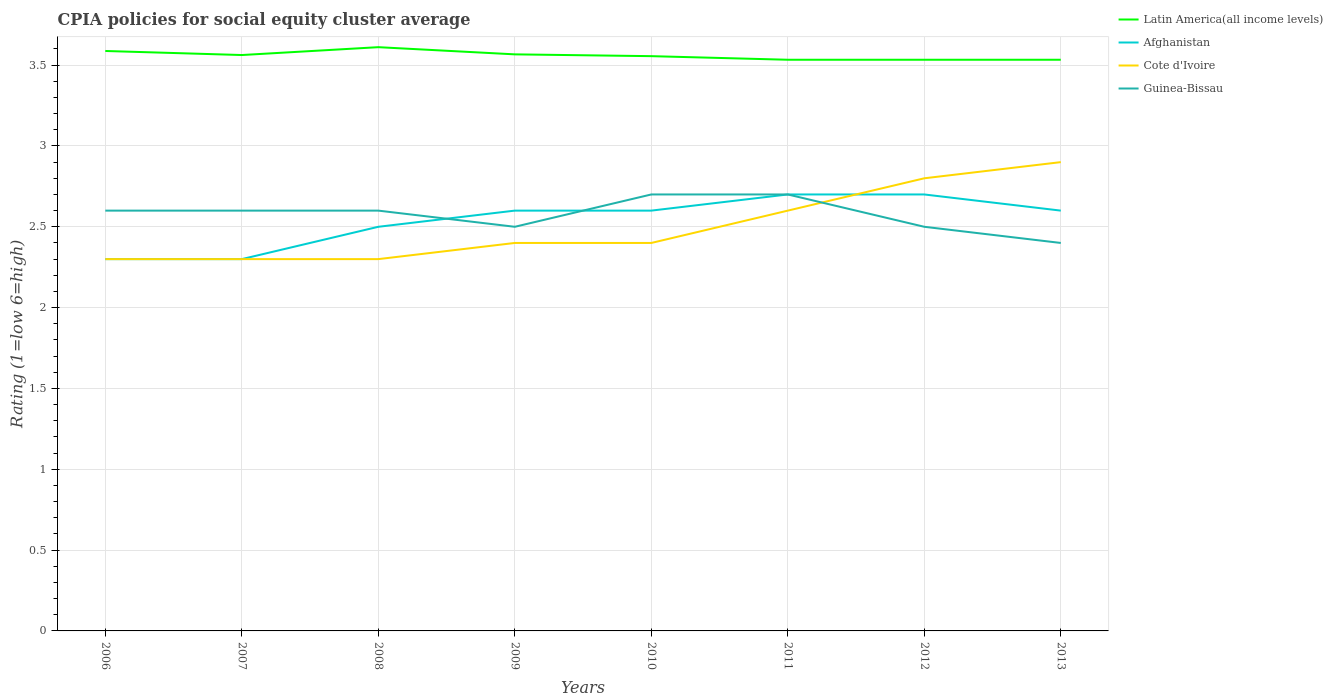Does the line corresponding to Latin America(all income levels) intersect with the line corresponding to Afghanistan?
Give a very brief answer. No. Across all years, what is the maximum CPIA rating in Latin America(all income levels)?
Ensure brevity in your answer.  3.53. What is the total CPIA rating in Afghanistan in the graph?
Offer a terse response. -0.3. What is the difference between the highest and the second highest CPIA rating in Guinea-Bissau?
Give a very brief answer. 0.3. What is the difference between two consecutive major ticks on the Y-axis?
Offer a very short reply. 0.5. Are the values on the major ticks of Y-axis written in scientific E-notation?
Your response must be concise. No. Does the graph contain any zero values?
Ensure brevity in your answer.  No. Does the graph contain grids?
Ensure brevity in your answer.  Yes. Where does the legend appear in the graph?
Keep it short and to the point. Top right. What is the title of the graph?
Offer a very short reply. CPIA policies for social equity cluster average. What is the label or title of the X-axis?
Your response must be concise. Years. What is the label or title of the Y-axis?
Your answer should be compact. Rating (1=low 6=high). What is the Rating (1=low 6=high) in Latin America(all income levels) in 2006?
Keep it short and to the point. 3.59. What is the Rating (1=low 6=high) in Latin America(all income levels) in 2007?
Offer a terse response. 3.56. What is the Rating (1=low 6=high) in Guinea-Bissau in 2007?
Your answer should be compact. 2.6. What is the Rating (1=low 6=high) in Latin America(all income levels) in 2008?
Ensure brevity in your answer.  3.61. What is the Rating (1=low 6=high) of Afghanistan in 2008?
Offer a very short reply. 2.5. What is the Rating (1=low 6=high) in Guinea-Bissau in 2008?
Provide a succinct answer. 2.6. What is the Rating (1=low 6=high) in Latin America(all income levels) in 2009?
Provide a succinct answer. 3.57. What is the Rating (1=low 6=high) in Cote d'Ivoire in 2009?
Offer a very short reply. 2.4. What is the Rating (1=low 6=high) in Guinea-Bissau in 2009?
Your answer should be very brief. 2.5. What is the Rating (1=low 6=high) in Latin America(all income levels) in 2010?
Make the answer very short. 3.56. What is the Rating (1=low 6=high) in Afghanistan in 2010?
Provide a succinct answer. 2.6. What is the Rating (1=low 6=high) in Guinea-Bissau in 2010?
Give a very brief answer. 2.7. What is the Rating (1=low 6=high) of Latin America(all income levels) in 2011?
Offer a very short reply. 3.53. What is the Rating (1=low 6=high) of Cote d'Ivoire in 2011?
Make the answer very short. 2.6. What is the Rating (1=low 6=high) of Latin America(all income levels) in 2012?
Your response must be concise. 3.53. What is the Rating (1=low 6=high) in Latin America(all income levels) in 2013?
Offer a terse response. 3.53. Across all years, what is the maximum Rating (1=low 6=high) of Latin America(all income levels)?
Ensure brevity in your answer.  3.61. Across all years, what is the maximum Rating (1=low 6=high) of Cote d'Ivoire?
Your answer should be very brief. 2.9. Across all years, what is the minimum Rating (1=low 6=high) of Latin America(all income levels)?
Make the answer very short. 3.53. Across all years, what is the minimum Rating (1=low 6=high) of Afghanistan?
Your response must be concise. 2.3. Across all years, what is the minimum Rating (1=low 6=high) of Guinea-Bissau?
Ensure brevity in your answer.  2.4. What is the total Rating (1=low 6=high) of Latin America(all income levels) in the graph?
Make the answer very short. 28.48. What is the total Rating (1=low 6=high) in Afghanistan in the graph?
Provide a short and direct response. 20.3. What is the total Rating (1=low 6=high) in Cote d'Ivoire in the graph?
Give a very brief answer. 20. What is the total Rating (1=low 6=high) of Guinea-Bissau in the graph?
Your answer should be compact. 20.6. What is the difference between the Rating (1=low 6=high) in Latin America(all income levels) in 2006 and that in 2007?
Make the answer very short. 0.03. What is the difference between the Rating (1=low 6=high) in Cote d'Ivoire in 2006 and that in 2007?
Your answer should be very brief. 0. What is the difference between the Rating (1=low 6=high) in Guinea-Bissau in 2006 and that in 2007?
Make the answer very short. 0. What is the difference between the Rating (1=low 6=high) in Latin America(all income levels) in 2006 and that in 2008?
Your answer should be compact. -0.02. What is the difference between the Rating (1=low 6=high) in Guinea-Bissau in 2006 and that in 2008?
Your answer should be compact. 0. What is the difference between the Rating (1=low 6=high) of Latin America(all income levels) in 2006 and that in 2009?
Your answer should be compact. 0.02. What is the difference between the Rating (1=low 6=high) of Latin America(all income levels) in 2006 and that in 2010?
Offer a very short reply. 0.03. What is the difference between the Rating (1=low 6=high) of Guinea-Bissau in 2006 and that in 2010?
Your answer should be very brief. -0.1. What is the difference between the Rating (1=low 6=high) in Latin America(all income levels) in 2006 and that in 2011?
Provide a succinct answer. 0.05. What is the difference between the Rating (1=low 6=high) in Cote d'Ivoire in 2006 and that in 2011?
Provide a short and direct response. -0.3. What is the difference between the Rating (1=low 6=high) of Guinea-Bissau in 2006 and that in 2011?
Provide a short and direct response. -0.1. What is the difference between the Rating (1=low 6=high) of Latin America(all income levels) in 2006 and that in 2012?
Give a very brief answer. 0.05. What is the difference between the Rating (1=low 6=high) of Afghanistan in 2006 and that in 2012?
Your answer should be compact. -0.4. What is the difference between the Rating (1=low 6=high) in Guinea-Bissau in 2006 and that in 2012?
Your answer should be compact. 0.1. What is the difference between the Rating (1=low 6=high) of Latin America(all income levels) in 2006 and that in 2013?
Keep it short and to the point. 0.05. What is the difference between the Rating (1=low 6=high) of Cote d'Ivoire in 2006 and that in 2013?
Give a very brief answer. -0.6. What is the difference between the Rating (1=low 6=high) in Guinea-Bissau in 2006 and that in 2013?
Offer a very short reply. 0.2. What is the difference between the Rating (1=low 6=high) in Latin America(all income levels) in 2007 and that in 2008?
Your answer should be very brief. -0.05. What is the difference between the Rating (1=low 6=high) of Afghanistan in 2007 and that in 2008?
Provide a succinct answer. -0.2. What is the difference between the Rating (1=low 6=high) of Latin America(all income levels) in 2007 and that in 2009?
Your answer should be compact. -0. What is the difference between the Rating (1=low 6=high) of Latin America(all income levels) in 2007 and that in 2010?
Your response must be concise. 0.01. What is the difference between the Rating (1=low 6=high) in Cote d'Ivoire in 2007 and that in 2010?
Ensure brevity in your answer.  -0.1. What is the difference between the Rating (1=low 6=high) in Guinea-Bissau in 2007 and that in 2010?
Provide a succinct answer. -0.1. What is the difference between the Rating (1=low 6=high) of Latin America(all income levels) in 2007 and that in 2011?
Make the answer very short. 0.03. What is the difference between the Rating (1=low 6=high) of Cote d'Ivoire in 2007 and that in 2011?
Your answer should be very brief. -0.3. What is the difference between the Rating (1=low 6=high) of Latin America(all income levels) in 2007 and that in 2012?
Ensure brevity in your answer.  0.03. What is the difference between the Rating (1=low 6=high) in Latin America(all income levels) in 2007 and that in 2013?
Offer a very short reply. 0.03. What is the difference between the Rating (1=low 6=high) in Afghanistan in 2007 and that in 2013?
Provide a short and direct response. -0.3. What is the difference between the Rating (1=low 6=high) of Guinea-Bissau in 2007 and that in 2013?
Your response must be concise. 0.2. What is the difference between the Rating (1=low 6=high) of Latin America(all income levels) in 2008 and that in 2009?
Ensure brevity in your answer.  0.04. What is the difference between the Rating (1=low 6=high) in Afghanistan in 2008 and that in 2009?
Ensure brevity in your answer.  -0.1. What is the difference between the Rating (1=low 6=high) in Guinea-Bissau in 2008 and that in 2009?
Offer a terse response. 0.1. What is the difference between the Rating (1=low 6=high) in Latin America(all income levels) in 2008 and that in 2010?
Keep it short and to the point. 0.06. What is the difference between the Rating (1=low 6=high) of Afghanistan in 2008 and that in 2010?
Your response must be concise. -0.1. What is the difference between the Rating (1=low 6=high) in Guinea-Bissau in 2008 and that in 2010?
Provide a succinct answer. -0.1. What is the difference between the Rating (1=low 6=high) of Latin America(all income levels) in 2008 and that in 2011?
Your answer should be compact. 0.08. What is the difference between the Rating (1=low 6=high) of Afghanistan in 2008 and that in 2011?
Offer a terse response. -0.2. What is the difference between the Rating (1=low 6=high) in Guinea-Bissau in 2008 and that in 2011?
Your response must be concise. -0.1. What is the difference between the Rating (1=low 6=high) of Latin America(all income levels) in 2008 and that in 2012?
Ensure brevity in your answer.  0.08. What is the difference between the Rating (1=low 6=high) in Cote d'Ivoire in 2008 and that in 2012?
Offer a very short reply. -0.5. What is the difference between the Rating (1=low 6=high) in Guinea-Bissau in 2008 and that in 2012?
Ensure brevity in your answer.  0.1. What is the difference between the Rating (1=low 6=high) in Latin America(all income levels) in 2008 and that in 2013?
Offer a terse response. 0.08. What is the difference between the Rating (1=low 6=high) in Cote d'Ivoire in 2008 and that in 2013?
Your answer should be compact. -0.6. What is the difference between the Rating (1=low 6=high) of Guinea-Bissau in 2008 and that in 2013?
Your answer should be very brief. 0.2. What is the difference between the Rating (1=low 6=high) in Latin America(all income levels) in 2009 and that in 2010?
Offer a terse response. 0.01. What is the difference between the Rating (1=low 6=high) in Guinea-Bissau in 2009 and that in 2010?
Ensure brevity in your answer.  -0.2. What is the difference between the Rating (1=low 6=high) in Latin America(all income levels) in 2009 and that in 2011?
Give a very brief answer. 0.03. What is the difference between the Rating (1=low 6=high) of Cote d'Ivoire in 2009 and that in 2011?
Provide a short and direct response. -0.2. What is the difference between the Rating (1=low 6=high) in Latin America(all income levels) in 2009 and that in 2012?
Give a very brief answer. 0.03. What is the difference between the Rating (1=low 6=high) in Guinea-Bissau in 2009 and that in 2012?
Offer a very short reply. 0. What is the difference between the Rating (1=low 6=high) in Latin America(all income levels) in 2009 and that in 2013?
Your answer should be compact. 0.03. What is the difference between the Rating (1=low 6=high) of Latin America(all income levels) in 2010 and that in 2011?
Give a very brief answer. 0.02. What is the difference between the Rating (1=low 6=high) of Latin America(all income levels) in 2010 and that in 2012?
Provide a short and direct response. 0.02. What is the difference between the Rating (1=low 6=high) of Afghanistan in 2010 and that in 2012?
Offer a terse response. -0.1. What is the difference between the Rating (1=low 6=high) of Latin America(all income levels) in 2010 and that in 2013?
Ensure brevity in your answer.  0.02. What is the difference between the Rating (1=low 6=high) in Afghanistan in 2010 and that in 2013?
Ensure brevity in your answer.  0. What is the difference between the Rating (1=low 6=high) of Guinea-Bissau in 2010 and that in 2013?
Ensure brevity in your answer.  0.3. What is the difference between the Rating (1=low 6=high) in Latin America(all income levels) in 2011 and that in 2012?
Keep it short and to the point. 0. What is the difference between the Rating (1=low 6=high) of Afghanistan in 2011 and that in 2012?
Ensure brevity in your answer.  0. What is the difference between the Rating (1=low 6=high) of Guinea-Bissau in 2011 and that in 2012?
Offer a very short reply. 0.2. What is the difference between the Rating (1=low 6=high) in Latin America(all income levels) in 2011 and that in 2013?
Keep it short and to the point. 0. What is the difference between the Rating (1=low 6=high) of Cote d'Ivoire in 2011 and that in 2013?
Keep it short and to the point. -0.3. What is the difference between the Rating (1=low 6=high) of Afghanistan in 2012 and that in 2013?
Offer a terse response. 0.1. What is the difference between the Rating (1=low 6=high) of Latin America(all income levels) in 2006 and the Rating (1=low 6=high) of Afghanistan in 2007?
Your answer should be compact. 1.29. What is the difference between the Rating (1=low 6=high) in Latin America(all income levels) in 2006 and the Rating (1=low 6=high) in Cote d'Ivoire in 2007?
Your response must be concise. 1.29. What is the difference between the Rating (1=low 6=high) of Latin America(all income levels) in 2006 and the Rating (1=low 6=high) of Guinea-Bissau in 2007?
Provide a succinct answer. 0.99. What is the difference between the Rating (1=low 6=high) in Afghanistan in 2006 and the Rating (1=low 6=high) in Guinea-Bissau in 2007?
Your response must be concise. -0.3. What is the difference between the Rating (1=low 6=high) in Cote d'Ivoire in 2006 and the Rating (1=low 6=high) in Guinea-Bissau in 2007?
Give a very brief answer. -0.3. What is the difference between the Rating (1=low 6=high) of Latin America(all income levels) in 2006 and the Rating (1=low 6=high) of Afghanistan in 2008?
Your answer should be very brief. 1.09. What is the difference between the Rating (1=low 6=high) in Latin America(all income levels) in 2006 and the Rating (1=low 6=high) in Cote d'Ivoire in 2008?
Provide a short and direct response. 1.29. What is the difference between the Rating (1=low 6=high) in Latin America(all income levels) in 2006 and the Rating (1=low 6=high) in Guinea-Bissau in 2008?
Your answer should be compact. 0.99. What is the difference between the Rating (1=low 6=high) of Latin America(all income levels) in 2006 and the Rating (1=low 6=high) of Afghanistan in 2009?
Ensure brevity in your answer.  0.99. What is the difference between the Rating (1=low 6=high) in Latin America(all income levels) in 2006 and the Rating (1=low 6=high) in Cote d'Ivoire in 2009?
Your answer should be compact. 1.19. What is the difference between the Rating (1=low 6=high) in Latin America(all income levels) in 2006 and the Rating (1=low 6=high) in Guinea-Bissau in 2009?
Provide a succinct answer. 1.09. What is the difference between the Rating (1=low 6=high) in Afghanistan in 2006 and the Rating (1=low 6=high) in Guinea-Bissau in 2009?
Make the answer very short. -0.2. What is the difference between the Rating (1=low 6=high) of Cote d'Ivoire in 2006 and the Rating (1=low 6=high) of Guinea-Bissau in 2009?
Offer a very short reply. -0.2. What is the difference between the Rating (1=low 6=high) of Latin America(all income levels) in 2006 and the Rating (1=low 6=high) of Afghanistan in 2010?
Provide a succinct answer. 0.99. What is the difference between the Rating (1=low 6=high) in Latin America(all income levels) in 2006 and the Rating (1=low 6=high) in Cote d'Ivoire in 2010?
Provide a short and direct response. 1.19. What is the difference between the Rating (1=low 6=high) of Latin America(all income levels) in 2006 and the Rating (1=low 6=high) of Guinea-Bissau in 2010?
Offer a very short reply. 0.89. What is the difference between the Rating (1=low 6=high) in Cote d'Ivoire in 2006 and the Rating (1=low 6=high) in Guinea-Bissau in 2010?
Provide a succinct answer. -0.4. What is the difference between the Rating (1=low 6=high) in Latin America(all income levels) in 2006 and the Rating (1=low 6=high) in Afghanistan in 2011?
Keep it short and to the point. 0.89. What is the difference between the Rating (1=low 6=high) in Latin America(all income levels) in 2006 and the Rating (1=low 6=high) in Cote d'Ivoire in 2011?
Provide a succinct answer. 0.99. What is the difference between the Rating (1=low 6=high) of Latin America(all income levels) in 2006 and the Rating (1=low 6=high) of Guinea-Bissau in 2011?
Provide a short and direct response. 0.89. What is the difference between the Rating (1=low 6=high) of Afghanistan in 2006 and the Rating (1=low 6=high) of Cote d'Ivoire in 2011?
Keep it short and to the point. -0.3. What is the difference between the Rating (1=low 6=high) in Afghanistan in 2006 and the Rating (1=low 6=high) in Guinea-Bissau in 2011?
Your answer should be compact. -0.4. What is the difference between the Rating (1=low 6=high) in Cote d'Ivoire in 2006 and the Rating (1=low 6=high) in Guinea-Bissau in 2011?
Your answer should be very brief. -0.4. What is the difference between the Rating (1=low 6=high) in Latin America(all income levels) in 2006 and the Rating (1=low 6=high) in Afghanistan in 2012?
Your answer should be compact. 0.89. What is the difference between the Rating (1=low 6=high) of Latin America(all income levels) in 2006 and the Rating (1=low 6=high) of Cote d'Ivoire in 2012?
Your response must be concise. 0.79. What is the difference between the Rating (1=low 6=high) in Latin America(all income levels) in 2006 and the Rating (1=low 6=high) in Guinea-Bissau in 2012?
Your response must be concise. 1.09. What is the difference between the Rating (1=low 6=high) of Afghanistan in 2006 and the Rating (1=low 6=high) of Guinea-Bissau in 2012?
Offer a terse response. -0.2. What is the difference between the Rating (1=low 6=high) of Latin America(all income levels) in 2006 and the Rating (1=low 6=high) of Afghanistan in 2013?
Your answer should be very brief. 0.99. What is the difference between the Rating (1=low 6=high) in Latin America(all income levels) in 2006 and the Rating (1=low 6=high) in Cote d'Ivoire in 2013?
Your answer should be compact. 0.69. What is the difference between the Rating (1=low 6=high) in Latin America(all income levels) in 2006 and the Rating (1=low 6=high) in Guinea-Bissau in 2013?
Ensure brevity in your answer.  1.19. What is the difference between the Rating (1=low 6=high) in Afghanistan in 2006 and the Rating (1=low 6=high) in Cote d'Ivoire in 2013?
Your response must be concise. -0.6. What is the difference between the Rating (1=low 6=high) in Latin America(all income levels) in 2007 and the Rating (1=low 6=high) in Afghanistan in 2008?
Ensure brevity in your answer.  1.06. What is the difference between the Rating (1=low 6=high) of Latin America(all income levels) in 2007 and the Rating (1=low 6=high) of Cote d'Ivoire in 2008?
Keep it short and to the point. 1.26. What is the difference between the Rating (1=low 6=high) of Latin America(all income levels) in 2007 and the Rating (1=low 6=high) of Guinea-Bissau in 2008?
Provide a short and direct response. 0.96. What is the difference between the Rating (1=low 6=high) of Latin America(all income levels) in 2007 and the Rating (1=low 6=high) of Afghanistan in 2009?
Make the answer very short. 0.96. What is the difference between the Rating (1=low 6=high) in Latin America(all income levels) in 2007 and the Rating (1=low 6=high) in Cote d'Ivoire in 2009?
Offer a very short reply. 1.16. What is the difference between the Rating (1=low 6=high) of Afghanistan in 2007 and the Rating (1=low 6=high) of Cote d'Ivoire in 2009?
Ensure brevity in your answer.  -0.1. What is the difference between the Rating (1=low 6=high) in Cote d'Ivoire in 2007 and the Rating (1=low 6=high) in Guinea-Bissau in 2009?
Give a very brief answer. -0.2. What is the difference between the Rating (1=low 6=high) of Latin America(all income levels) in 2007 and the Rating (1=low 6=high) of Afghanistan in 2010?
Provide a succinct answer. 0.96. What is the difference between the Rating (1=low 6=high) of Latin America(all income levels) in 2007 and the Rating (1=low 6=high) of Cote d'Ivoire in 2010?
Ensure brevity in your answer.  1.16. What is the difference between the Rating (1=low 6=high) of Latin America(all income levels) in 2007 and the Rating (1=low 6=high) of Guinea-Bissau in 2010?
Make the answer very short. 0.86. What is the difference between the Rating (1=low 6=high) of Latin America(all income levels) in 2007 and the Rating (1=low 6=high) of Afghanistan in 2011?
Provide a short and direct response. 0.86. What is the difference between the Rating (1=low 6=high) in Latin America(all income levels) in 2007 and the Rating (1=low 6=high) in Cote d'Ivoire in 2011?
Keep it short and to the point. 0.96. What is the difference between the Rating (1=low 6=high) in Latin America(all income levels) in 2007 and the Rating (1=low 6=high) in Guinea-Bissau in 2011?
Offer a very short reply. 0.86. What is the difference between the Rating (1=low 6=high) of Afghanistan in 2007 and the Rating (1=low 6=high) of Cote d'Ivoire in 2011?
Provide a short and direct response. -0.3. What is the difference between the Rating (1=low 6=high) in Afghanistan in 2007 and the Rating (1=low 6=high) in Guinea-Bissau in 2011?
Keep it short and to the point. -0.4. What is the difference between the Rating (1=low 6=high) in Cote d'Ivoire in 2007 and the Rating (1=low 6=high) in Guinea-Bissau in 2011?
Provide a short and direct response. -0.4. What is the difference between the Rating (1=low 6=high) of Latin America(all income levels) in 2007 and the Rating (1=low 6=high) of Afghanistan in 2012?
Your answer should be compact. 0.86. What is the difference between the Rating (1=low 6=high) of Latin America(all income levels) in 2007 and the Rating (1=low 6=high) of Cote d'Ivoire in 2012?
Offer a very short reply. 0.76. What is the difference between the Rating (1=low 6=high) in Latin America(all income levels) in 2007 and the Rating (1=low 6=high) in Guinea-Bissau in 2012?
Your answer should be compact. 1.06. What is the difference between the Rating (1=low 6=high) in Afghanistan in 2007 and the Rating (1=low 6=high) in Cote d'Ivoire in 2012?
Your response must be concise. -0.5. What is the difference between the Rating (1=low 6=high) in Cote d'Ivoire in 2007 and the Rating (1=low 6=high) in Guinea-Bissau in 2012?
Give a very brief answer. -0.2. What is the difference between the Rating (1=low 6=high) of Latin America(all income levels) in 2007 and the Rating (1=low 6=high) of Afghanistan in 2013?
Offer a terse response. 0.96. What is the difference between the Rating (1=low 6=high) in Latin America(all income levels) in 2007 and the Rating (1=low 6=high) in Cote d'Ivoire in 2013?
Keep it short and to the point. 0.66. What is the difference between the Rating (1=low 6=high) in Latin America(all income levels) in 2007 and the Rating (1=low 6=high) in Guinea-Bissau in 2013?
Make the answer very short. 1.16. What is the difference between the Rating (1=low 6=high) of Latin America(all income levels) in 2008 and the Rating (1=low 6=high) of Afghanistan in 2009?
Provide a short and direct response. 1.01. What is the difference between the Rating (1=low 6=high) of Latin America(all income levels) in 2008 and the Rating (1=low 6=high) of Cote d'Ivoire in 2009?
Offer a very short reply. 1.21. What is the difference between the Rating (1=low 6=high) in Latin America(all income levels) in 2008 and the Rating (1=low 6=high) in Guinea-Bissau in 2009?
Your response must be concise. 1.11. What is the difference between the Rating (1=low 6=high) in Afghanistan in 2008 and the Rating (1=low 6=high) in Cote d'Ivoire in 2009?
Offer a very short reply. 0.1. What is the difference between the Rating (1=low 6=high) in Afghanistan in 2008 and the Rating (1=low 6=high) in Guinea-Bissau in 2009?
Your answer should be compact. 0. What is the difference between the Rating (1=low 6=high) of Cote d'Ivoire in 2008 and the Rating (1=low 6=high) of Guinea-Bissau in 2009?
Ensure brevity in your answer.  -0.2. What is the difference between the Rating (1=low 6=high) of Latin America(all income levels) in 2008 and the Rating (1=low 6=high) of Afghanistan in 2010?
Keep it short and to the point. 1.01. What is the difference between the Rating (1=low 6=high) of Latin America(all income levels) in 2008 and the Rating (1=low 6=high) of Cote d'Ivoire in 2010?
Make the answer very short. 1.21. What is the difference between the Rating (1=low 6=high) in Latin America(all income levels) in 2008 and the Rating (1=low 6=high) in Guinea-Bissau in 2010?
Ensure brevity in your answer.  0.91. What is the difference between the Rating (1=low 6=high) of Latin America(all income levels) in 2008 and the Rating (1=low 6=high) of Afghanistan in 2011?
Provide a short and direct response. 0.91. What is the difference between the Rating (1=low 6=high) in Latin America(all income levels) in 2008 and the Rating (1=low 6=high) in Cote d'Ivoire in 2011?
Offer a terse response. 1.01. What is the difference between the Rating (1=low 6=high) of Latin America(all income levels) in 2008 and the Rating (1=low 6=high) of Guinea-Bissau in 2011?
Give a very brief answer. 0.91. What is the difference between the Rating (1=low 6=high) in Afghanistan in 2008 and the Rating (1=low 6=high) in Cote d'Ivoire in 2011?
Ensure brevity in your answer.  -0.1. What is the difference between the Rating (1=low 6=high) in Cote d'Ivoire in 2008 and the Rating (1=low 6=high) in Guinea-Bissau in 2011?
Provide a short and direct response. -0.4. What is the difference between the Rating (1=low 6=high) of Latin America(all income levels) in 2008 and the Rating (1=low 6=high) of Afghanistan in 2012?
Keep it short and to the point. 0.91. What is the difference between the Rating (1=low 6=high) in Latin America(all income levels) in 2008 and the Rating (1=low 6=high) in Cote d'Ivoire in 2012?
Provide a short and direct response. 0.81. What is the difference between the Rating (1=low 6=high) of Latin America(all income levels) in 2008 and the Rating (1=low 6=high) of Guinea-Bissau in 2012?
Ensure brevity in your answer.  1.11. What is the difference between the Rating (1=low 6=high) in Afghanistan in 2008 and the Rating (1=low 6=high) in Cote d'Ivoire in 2012?
Give a very brief answer. -0.3. What is the difference between the Rating (1=low 6=high) in Afghanistan in 2008 and the Rating (1=low 6=high) in Guinea-Bissau in 2012?
Make the answer very short. 0. What is the difference between the Rating (1=low 6=high) of Cote d'Ivoire in 2008 and the Rating (1=low 6=high) of Guinea-Bissau in 2012?
Give a very brief answer. -0.2. What is the difference between the Rating (1=low 6=high) in Latin America(all income levels) in 2008 and the Rating (1=low 6=high) in Afghanistan in 2013?
Offer a terse response. 1.01. What is the difference between the Rating (1=low 6=high) of Latin America(all income levels) in 2008 and the Rating (1=low 6=high) of Cote d'Ivoire in 2013?
Ensure brevity in your answer.  0.71. What is the difference between the Rating (1=low 6=high) in Latin America(all income levels) in 2008 and the Rating (1=low 6=high) in Guinea-Bissau in 2013?
Make the answer very short. 1.21. What is the difference between the Rating (1=low 6=high) in Afghanistan in 2008 and the Rating (1=low 6=high) in Cote d'Ivoire in 2013?
Your response must be concise. -0.4. What is the difference between the Rating (1=low 6=high) of Cote d'Ivoire in 2008 and the Rating (1=low 6=high) of Guinea-Bissau in 2013?
Ensure brevity in your answer.  -0.1. What is the difference between the Rating (1=low 6=high) in Latin America(all income levels) in 2009 and the Rating (1=low 6=high) in Afghanistan in 2010?
Your answer should be very brief. 0.97. What is the difference between the Rating (1=low 6=high) in Latin America(all income levels) in 2009 and the Rating (1=low 6=high) in Cote d'Ivoire in 2010?
Provide a succinct answer. 1.17. What is the difference between the Rating (1=low 6=high) in Latin America(all income levels) in 2009 and the Rating (1=low 6=high) in Guinea-Bissau in 2010?
Ensure brevity in your answer.  0.87. What is the difference between the Rating (1=low 6=high) of Latin America(all income levels) in 2009 and the Rating (1=low 6=high) of Afghanistan in 2011?
Ensure brevity in your answer.  0.87. What is the difference between the Rating (1=low 6=high) of Latin America(all income levels) in 2009 and the Rating (1=low 6=high) of Cote d'Ivoire in 2011?
Provide a succinct answer. 0.97. What is the difference between the Rating (1=low 6=high) in Latin America(all income levels) in 2009 and the Rating (1=low 6=high) in Guinea-Bissau in 2011?
Offer a terse response. 0.87. What is the difference between the Rating (1=low 6=high) in Afghanistan in 2009 and the Rating (1=low 6=high) in Cote d'Ivoire in 2011?
Your answer should be very brief. 0. What is the difference between the Rating (1=low 6=high) in Afghanistan in 2009 and the Rating (1=low 6=high) in Guinea-Bissau in 2011?
Your answer should be very brief. -0.1. What is the difference between the Rating (1=low 6=high) in Cote d'Ivoire in 2009 and the Rating (1=low 6=high) in Guinea-Bissau in 2011?
Your answer should be compact. -0.3. What is the difference between the Rating (1=low 6=high) in Latin America(all income levels) in 2009 and the Rating (1=low 6=high) in Afghanistan in 2012?
Ensure brevity in your answer.  0.87. What is the difference between the Rating (1=low 6=high) in Latin America(all income levels) in 2009 and the Rating (1=low 6=high) in Cote d'Ivoire in 2012?
Provide a short and direct response. 0.77. What is the difference between the Rating (1=low 6=high) of Latin America(all income levels) in 2009 and the Rating (1=low 6=high) of Guinea-Bissau in 2012?
Provide a succinct answer. 1.07. What is the difference between the Rating (1=low 6=high) in Afghanistan in 2009 and the Rating (1=low 6=high) in Guinea-Bissau in 2012?
Keep it short and to the point. 0.1. What is the difference between the Rating (1=low 6=high) in Latin America(all income levels) in 2009 and the Rating (1=low 6=high) in Afghanistan in 2013?
Keep it short and to the point. 0.97. What is the difference between the Rating (1=low 6=high) of Latin America(all income levels) in 2009 and the Rating (1=low 6=high) of Guinea-Bissau in 2013?
Give a very brief answer. 1.17. What is the difference between the Rating (1=low 6=high) of Cote d'Ivoire in 2009 and the Rating (1=low 6=high) of Guinea-Bissau in 2013?
Provide a short and direct response. 0. What is the difference between the Rating (1=low 6=high) in Latin America(all income levels) in 2010 and the Rating (1=low 6=high) in Afghanistan in 2011?
Ensure brevity in your answer.  0.86. What is the difference between the Rating (1=low 6=high) in Latin America(all income levels) in 2010 and the Rating (1=low 6=high) in Cote d'Ivoire in 2011?
Provide a succinct answer. 0.96. What is the difference between the Rating (1=low 6=high) of Latin America(all income levels) in 2010 and the Rating (1=low 6=high) of Guinea-Bissau in 2011?
Make the answer very short. 0.86. What is the difference between the Rating (1=low 6=high) in Afghanistan in 2010 and the Rating (1=low 6=high) in Cote d'Ivoire in 2011?
Your response must be concise. 0. What is the difference between the Rating (1=low 6=high) in Afghanistan in 2010 and the Rating (1=low 6=high) in Guinea-Bissau in 2011?
Provide a short and direct response. -0.1. What is the difference between the Rating (1=low 6=high) in Cote d'Ivoire in 2010 and the Rating (1=low 6=high) in Guinea-Bissau in 2011?
Offer a terse response. -0.3. What is the difference between the Rating (1=low 6=high) of Latin America(all income levels) in 2010 and the Rating (1=low 6=high) of Afghanistan in 2012?
Make the answer very short. 0.86. What is the difference between the Rating (1=low 6=high) in Latin America(all income levels) in 2010 and the Rating (1=low 6=high) in Cote d'Ivoire in 2012?
Your answer should be compact. 0.76. What is the difference between the Rating (1=low 6=high) of Latin America(all income levels) in 2010 and the Rating (1=low 6=high) of Guinea-Bissau in 2012?
Give a very brief answer. 1.06. What is the difference between the Rating (1=low 6=high) in Afghanistan in 2010 and the Rating (1=low 6=high) in Cote d'Ivoire in 2012?
Offer a terse response. -0.2. What is the difference between the Rating (1=low 6=high) in Afghanistan in 2010 and the Rating (1=low 6=high) in Guinea-Bissau in 2012?
Make the answer very short. 0.1. What is the difference between the Rating (1=low 6=high) of Cote d'Ivoire in 2010 and the Rating (1=low 6=high) of Guinea-Bissau in 2012?
Provide a succinct answer. -0.1. What is the difference between the Rating (1=low 6=high) of Latin America(all income levels) in 2010 and the Rating (1=low 6=high) of Afghanistan in 2013?
Offer a very short reply. 0.96. What is the difference between the Rating (1=low 6=high) of Latin America(all income levels) in 2010 and the Rating (1=low 6=high) of Cote d'Ivoire in 2013?
Give a very brief answer. 0.66. What is the difference between the Rating (1=low 6=high) of Latin America(all income levels) in 2010 and the Rating (1=low 6=high) of Guinea-Bissau in 2013?
Your response must be concise. 1.16. What is the difference between the Rating (1=low 6=high) of Afghanistan in 2010 and the Rating (1=low 6=high) of Cote d'Ivoire in 2013?
Your response must be concise. -0.3. What is the difference between the Rating (1=low 6=high) in Afghanistan in 2010 and the Rating (1=low 6=high) in Guinea-Bissau in 2013?
Your answer should be very brief. 0.2. What is the difference between the Rating (1=low 6=high) in Latin America(all income levels) in 2011 and the Rating (1=low 6=high) in Afghanistan in 2012?
Provide a succinct answer. 0.83. What is the difference between the Rating (1=low 6=high) in Latin America(all income levels) in 2011 and the Rating (1=low 6=high) in Cote d'Ivoire in 2012?
Your answer should be compact. 0.73. What is the difference between the Rating (1=low 6=high) in Afghanistan in 2011 and the Rating (1=low 6=high) in Cote d'Ivoire in 2012?
Make the answer very short. -0.1. What is the difference between the Rating (1=low 6=high) of Latin America(all income levels) in 2011 and the Rating (1=low 6=high) of Cote d'Ivoire in 2013?
Offer a terse response. 0.63. What is the difference between the Rating (1=low 6=high) in Latin America(all income levels) in 2011 and the Rating (1=low 6=high) in Guinea-Bissau in 2013?
Provide a short and direct response. 1.13. What is the difference between the Rating (1=low 6=high) of Afghanistan in 2011 and the Rating (1=low 6=high) of Guinea-Bissau in 2013?
Provide a short and direct response. 0.3. What is the difference between the Rating (1=low 6=high) in Cote d'Ivoire in 2011 and the Rating (1=low 6=high) in Guinea-Bissau in 2013?
Keep it short and to the point. 0.2. What is the difference between the Rating (1=low 6=high) in Latin America(all income levels) in 2012 and the Rating (1=low 6=high) in Cote d'Ivoire in 2013?
Your answer should be compact. 0.63. What is the difference between the Rating (1=low 6=high) in Latin America(all income levels) in 2012 and the Rating (1=low 6=high) in Guinea-Bissau in 2013?
Ensure brevity in your answer.  1.13. What is the difference between the Rating (1=low 6=high) in Afghanistan in 2012 and the Rating (1=low 6=high) in Cote d'Ivoire in 2013?
Give a very brief answer. -0.2. What is the average Rating (1=low 6=high) in Latin America(all income levels) per year?
Provide a short and direct response. 3.56. What is the average Rating (1=low 6=high) of Afghanistan per year?
Provide a short and direct response. 2.54. What is the average Rating (1=low 6=high) in Cote d'Ivoire per year?
Your answer should be compact. 2.5. What is the average Rating (1=low 6=high) in Guinea-Bissau per year?
Make the answer very short. 2.58. In the year 2006, what is the difference between the Rating (1=low 6=high) of Latin America(all income levels) and Rating (1=low 6=high) of Afghanistan?
Your response must be concise. 1.29. In the year 2006, what is the difference between the Rating (1=low 6=high) in Latin America(all income levels) and Rating (1=low 6=high) in Cote d'Ivoire?
Your answer should be very brief. 1.29. In the year 2006, what is the difference between the Rating (1=low 6=high) in Latin America(all income levels) and Rating (1=low 6=high) in Guinea-Bissau?
Make the answer very short. 0.99. In the year 2006, what is the difference between the Rating (1=low 6=high) in Afghanistan and Rating (1=low 6=high) in Cote d'Ivoire?
Give a very brief answer. 0. In the year 2007, what is the difference between the Rating (1=low 6=high) of Latin America(all income levels) and Rating (1=low 6=high) of Afghanistan?
Offer a very short reply. 1.26. In the year 2007, what is the difference between the Rating (1=low 6=high) of Latin America(all income levels) and Rating (1=low 6=high) of Cote d'Ivoire?
Keep it short and to the point. 1.26. In the year 2007, what is the difference between the Rating (1=low 6=high) in Latin America(all income levels) and Rating (1=low 6=high) in Guinea-Bissau?
Keep it short and to the point. 0.96. In the year 2007, what is the difference between the Rating (1=low 6=high) of Afghanistan and Rating (1=low 6=high) of Cote d'Ivoire?
Give a very brief answer. 0. In the year 2008, what is the difference between the Rating (1=low 6=high) of Latin America(all income levels) and Rating (1=low 6=high) of Cote d'Ivoire?
Ensure brevity in your answer.  1.31. In the year 2008, what is the difference between the Rating (1=low 6=high) of Latin America(all income levels) and Rating (1=low 6=high) of Guinea-Bissau?
Offer a very short reply. 1.01. In the year 2008, what is the difference between the Rating (1=low 6=high) of Afghanistan and Rating (1=low 6=high) of Guinea-Bissau?
Give a very brief answer. -0.1. In the year 2009, what is the difference between the Rating (1=low 6=high) of Latin America(all income levels) and Rating (1=low 6=high) of Afghanistan?
Give a very brief answer. 0.97. In the year 2009, what is the difference between the Rating (1=low 6=high) of Latin America(all income levels) and Rating (1=low 6=high) of Guinea-Bissau?
Give a very brief answer. 1.07. In the year 2009, what is the difference between the Rating (1=low 6=high) in Afghanistan and Rating (1=low 6=high) in Cote d'Ivoire?
Keep it short and to the point. 0.2. In the year 2009, what is the difference between the Rating (1=low 6=high) of Cote d'Ivoire and Rating (1=low 6=high) of Guinea-Bissau?
Your response must be concise. -0.1. In the year 2010, what is the difference between the Rating (1=low 6=high) of Latin America(all income levels) and Rating (1=low 6=high) of Afghanistan?
Your response must be concise. 0.96. In the year 2010, what is the difference between the Rating (1=low 6=high) in Latin America(all income levels) and Rating (1=low 6=high) in Cote d'Ivoire?
Provide a short and direct response. 1.16. In the year 2010, what is the difference between the Rating (1=low 6=high) in Latin America(all income levels) and Rating (1=low 6=high) in Guinea-Bissau?
Provide a short and direct response. 0.86. In the year 2010, what is the difference between the Rating (1=low 6=high) of Afghanistan and Rating (1=low 6=high) of Guinea-Bissau?
Make the answer very short. -0.1. In the year 2010, what is the difference between the Rating (1=low 6=high) of Cote d'Ivoire and Rating (1=low 6=high) of Guinea-Bissau?
Provide a succinct answer. -0.3. In the year 2011, what is the difference between the Rating (1=low 6=high) of Latin America(all income levels) and Rating (1=low 6=high) of Afghanistan?
Offer a very short reply. 0.83. In the year 2011, what is the difference between the Rating (1=low 6=high) in Latin America(all income levels) and Rating (1=low 6=high) in Cote d'Ivoire?
Offer a terse response. 0.93. In the year 2011, what is the difference between the Rating (1=low 6=high) of Latin America(all income levels) and Rating (1=low 6=high) of Guinea-Bissau?
Offer a terse response. 0.83. In the year 2011, what is the difference between the Rating (1=low 6=high) in Afghanistan and Rating (1=low 6=high) in Cote d'Ivoire?
Provide a succinct answer. 0.1. In the year 2011, what is the difference between the Rating (1=low 6=high) in Afghanistan and Rating (1=low 6=high) in Guinea-Bissau?
Your answer should be very brief. 0. In the year 2012, what is the difference between the Rating (1=low 6=high) in Latin America(all income levels) and Rating (1=low 6=high) in Afghanistan?
Offer a very short reply. 0.83. In the year 2012, what is the difference between the Rating (1=low 6=high) of Latin America(all income levels) and Rating (1=low 6=high) of Cote d'Ivoire?
Give a very brief answer. 0.73. In the year 2012, what is the difference between the Rating (1=low 6=high) in Latin America(all income levels) and Rating (1=low 6=high) in Guinea-Bissau?
Keep it short and to the point. 1.03. In the year 2012, what is the difference between the Rating (1=low 6=high) in Afghanistan and Rating (1=low 6=high) in Cote d'Ivoire?
Provide a short and direct response. -0.1. In the year 2012, what is the difference between the Rating (1=low 6=high) in Afghanistan and Rating (1=low 6=high) in Guinea-Bissau?
Give a very brief answer. 0.2. In the year 2012, what is the difference between the Rating (1=low 6=high) in Cote d'Ivoire and Rating (1=low 6=high) in Guinea-Bissau?
Your answer should be very brief. 0.3. In the year 2013, what is the difference between the Rating (1=low 6=high) in Latin America(all income levels) and Rating (1=low 6=high) in Afghanistan?
Your answer should be very brief. 0.93. In the year 2013, what is the difference between the Rating (1=low 6=high) in Latin America(all income levels) and Rating (1=low 6=high) in Cote d'Ivoire?
Your response must be concise. 0.63. In the year 2013, what is the difference between the Rating (1=low 6=high) of Latin America(all income levels) and Rating (1=low 6=high) of Guinea-Bissau?
Ensure brevity in your answer.  1.13. What is the ratio of the Rating (1=low 6=high) of Latin America(all income levels) in 2006 to that in 2007?
Your response must be concise. 1.01. What is the ratio of the Rating (1=low 6=high) of Cote d'Ivoire in 2006 to that in 2007?
Your answer should be compact. 1. What is the ratio of the Rating (1=low 6=high) of Guinea-Bissau in 2006 to that in 2007?
Your response must be concise. 1. What is the ratio of the Rating (1=low 6=high) of Afghanistan in 2006 to that in 2008?
Provide a short and direct response. 0.92. What is the ratio of the Rating (1=low 6=high) in Afghanistan in 2006 to that in 2009?
Provide a succinct answer. 0.88. What is the ratio of the Rating (1=low 6=high) of Latin America(all income levels) in 2006 to that in 2010?
Provide a succinct answer. 1.01. What is the ratio of the Rating (1=low 6=high) of Afghanistan in 2006 to that in 2010?
Ensure brevity in your answer.  0.88. What is the ratio of the Rating (1=low 6=high) in Guinea-Bissau in 2006 to that in 2010?
Give a very brief answer. 0.96. What is the ratio of the Rating (1=low 6=high) of Latin America(all income levels) in 2006 to that in 2011?
Give a very brief answer. 1.02. What is the ratio of the Rating (1=low 6=high) in Afghanistan in 2006 to that in 2011?
Provide a succinct answer. 0.85. What is the ratio of the Rating (1=low 6=high) of Cote d'Ivoire in 2006 to that in 2011?
Your answer should be compact. 0.88. What is the ratio of the Rating (1=low 6=high) of Guinea-Bissau in 2006 to that in 2011?
Provide a short and direct response. 0.96. What is the ratio of the Rating (1=low 6=high) of Latin America(all income levels) in 2006 to that in 2012?
Provide a short and direct response. 1.02. What is the ratio of the Rating (1=low 6=high) of Afghanistan in 2006 to that in 2012?
Give a very brief answer. 0.85. What is the ratio of the Rating (1=low 6=high) of Cote d'Ivoire in 2006 to that in 2012?
Your answer should be compact. 0.82. What is the ratio of the Rating (1=low 6=high) in Latin America(all income levels) in 2006 to that in 2013?
Provide a succinct answer. 1.02. What is the ratio of the Rating (1=low 6=high) in Afghanistan in 2006 to that in 2013?
Offer a terse response. 0.88. What is the ratio of the Rating (1=low 6=high) in Cote d'Ivoire in 2006 to that in 2013?
Your response must be concise. 0.79. What is the ratio of the Rating (1=low 6=high) of Latin America(all income levels) in 2007 to that in 2008?
Your answer should be very brief. 0.99. What is the ratio of the Rating (1=low 6=high) of Guinea-Bissau in 2007 to that in 2008?
Keep it short and to the point. 1. What is the ratio of the Rating (1=low 6=high) of Latin America(all income levels) in 2007 to that in 2009?
Offer a very short reply. 1. What is the ratio of the Rating (1=low 6=high) in Afghanistan in 2007 to that in 2009?
Keep it short and to the point. 0.88. What is the ratio of the Rating (1=low 6=high) in Cote d'Ivoire in 2007 to that in 2009?
Ensure brevity in your answer.  0.96. What is the ratio of the Rating (1=low 6=high) in Guinea-Bissau in 2007 to that in 2009?
Offer a terse response. 1.04. What is the ratio of the Rating (1=low 6=high) of Afghanistan in 2007 to that in 2010?
Provide a succinct answer. 0.88. What is the ratio of the Rating (1=low 6=high) of Latin America(all income levels) in 2007 to that in 2011?
Your response must be concise. 1.01. What is the ratio of the Rating (1=low 6=high) in Afghanistan in 2007 to that in 2011?
Your answer should be very brief. 0.85. What is the ratio of the Rating (1=low 6=high) of Cote d'Ivoire in 2007 to that in 2011?
Your answer should be compact. 0.88. What is the ratio of the Rating (1=low 6=high) of Guinea-Bissau in 2007 to that in 2011?
Ensure brevity in your answer.  0.96. What is the ratio of the Rating (1=low 6=high) in Latin America(all income levels) in 2007 to that in 2012?
Make the answer very short. 1.01. What is the ratio of the Rating (1=low 6=high) of Afghanistan in 2007 to that in 2012?
Keep it short and to the point. 0.85. What is the ratio of the Rating (1=low 6=high) in Cote d'Ivoire in 2007 to that in 2012?
Your answer should be compact. 0.82. What is the ratio of the Rating (1=low 6=high) in Guinea-Bissau in 2007 to that in 2012?
Your answer should be compact. 1.04. What is the ratio of the Rating (1=low 6=high) in Latin America(all income levels) in 2007 to that in 2013?
Ensure brevity in your answer.  1.01. What is the ratio of the Rating (1=low 6=high) of Afghanistan in 2007 to that in 2013?
Your response must be concise. 0.88. What is the ratio of the Rating (1=low 6=high) in Cote d'Ivoire in 2007 to that in 2013?
Your answer should be compact. 0.79. What is the ratio of the Rating (1=low 6=high) in Guinea-Bissau in 2007 to that in 2013?
Your response must be concise. 1.08. What is the ratio of the Rating (1=low 6=high) of Latin America(all income levels) in 2008 to that in 2009?
Your answer should be very brief. 1.01. What is the ratio of the Rating (1=low 6=high) in Afghanistan in 2008 to that in 2009?
Give a very brief answer. 0.96. What is the ratio of the Rating (1=low 6=high) in Cote d'Ivoire in 2008 to that in 2009?
Your answer should be very brief. 0.96. What is the ratio of the Rating (1=low 6=high) in Latin America(all income levels) in 2008 to that in 2010?
Give a very brief answer. 1.02. What is the ratio of the Rating (1=low 6=high) in Afghanistan in 2008 to that in 2010?
Keep it short and to the point. 0.96. What is the ratio of the Rating (1=low 6=high) of Afghanistan in 2008 to that in 2011?
Your response must be concise. 0.93. What is the ratio of the Rating (1=low 6=high) of Cote d'Ivoire in 2008 to that in 2011?
Provide a succinct answer. 0.88. What is the ratio of the Rating (1=low 6=high) of Latin America(all income levels) in 2008 to that in 2012?
Offer a very short reply. 1.02. What is the ratio of the Rating (1=low 6=high) in Afghanistan in 2008 to that in 2012?
Offer a very short reply. 0.93. What is the ratio of the Rating (1=low 6=high) of Cote d'Ivoire in 2008 to that in 2012?
Ensure brevity in your answer.  0.82. What is the ratio of the Rating (1=low 6=high) of Guinea-Bissau in 2008 to that in 2012?
Ensure brevity in your answer.  1.04. What is the ratio of the Rating (1=low 6=high) of Afghanistan in 2008 to that in 2013?
Your answer should be compact. 0.96. What is the ratio of the Rating (1=low 6=high) of Cote d'Ivoire in 2008 to that in 2013?
Keep it short and to the point. 0.79. What is the ratio of the Rating (1=low 6=high) in Latin America(all income levels) in 2009 to that in 2010?
Your answer should be very brief. 1. What is the ratio of the Rating (1=low 6=high) of Cote d'Ivoire in 2009 to that in 2010?
Your response must be concise. 1. What is the ratio of the Rating (1=low 6=high) in Guinea-Bissau in 2009 to that in 2010?
Offer a terse response. 0.93. What is the ratio of the Rating (1=low 6=high) in Latin America(all income levels) in 2009 to that in 2011?
Provide a succinct answer. 1.01. What is the ratio of the Rating (1=low 6=high) of Afghanistan in 2009 to that in 2011?
Your answer should be compact. 0.96. What is the ratio of the Rating (1=low 6=high) of Guinea-Bissau in 2009 to that in 2011?
Provide a succinct answer. 0.93. What is the ratio of the Rating (1=low 6=high) in Latin America(all income levels) in 2009 to that in 2012?
Your response must be concise. 1.01. What is the ratio of the Rating (1=low 6=high) in Afghanistan in 2009 to that in 2012?
Your answer should be compact. 0.96. What is the ratio of the Rating (1=low 6=high) in Cote d'Ivoire in 2009 to that in 2012?
Make the answer very short. 0.86. What is the ratio of the Rating (1=low 6=high) of Guinea-Bissau in 2009 to that in 2012?
Keep it short and to the point. 1. What is the ratio of the Rating (1=low 6=high) of Latin America(all income levels) in 2009 to that in 2013?
Give a very brief answer. 1.01. What is the ratio of the Rating (1=low 6=high) in Cote d'Ivoire in 2009 to that in 2013?
Your answer should be very brief. 0.83. What is the ratio of the Rating (1=low 6=high) of Guinea-Bissau in 2009 to that in 2013?
Provide a short and direct response. 1.04. What is the ratio of the Rating (1=low 6=high) in Latin America(all income levels) in 2010 to that in 2011?
Ensure brevity in your answer.  1.01. What is the ratio of the Rating (1=low 6=high) in Cote d'Ivoire in 2010 to that in 2011?
Keep it short and to the point. 0.92. What is the ratio of the Rating (1=low 6=high) in Latin America(all income levels) in 2010 to that in 2012?
Offer a terse response. 1.01. What is the ratio of the Rating (1=low 6=high) in Cote d'Ivoire in 2010 to that in 2012?
Give a very brief answer. 0.86. What is the ratio of the Rating (1=low 6=high) of Guinea-Bissau in 2010 to that in 2012?
Make the answer very short. 1.08. What is the ratio of the Rating (1=low 6=high) of Cote d'Ivoire in 2010 to that in 2013?
Ensure brevity in your answer.  0.83. What is the ratio of the Rating (1=low 6=high) in Guinea-Bissau in 2010 to that in 2013?
Your response must be concise. 1.12. What is the ratio of the Rating (1=low 6=high) of Afghanistan in 2011 to that in 2012?
Give a very brief answer. 1. What is the ratio of the Rating (1=low 6=high) of Cote d'Ivoire in 2011 to that in 2012?
Offer a terse response. 0.93. What is the ratio of the Rating (1=low 6=high) in Guinea-Bissau in 2011 to that in 2012?
Provide a short and direct response. 1.08. What is the ratio of the Rating (1=low 6=high) in Afghanistan in 2011 to that in 2013?
Your answer should be very brief. 1.04. What is the ratio of the Rating (1=low 6=high) of Cote d'Ivoire in 2011 to that in 2013?
Provide a succinct answer. 0.9. What is the ratio of the Rating (1=low 6=high) in Guinea-Bissau in 2011 to that in 2013?
Your answer should be very brief. 1.12. What is the ratio of the Rating (1=low 6=high) in Afghanistan in 2012 to that in 2013?
Keep it short and to the point. 1.04. What is the ratio of the Rating (1=low 6=high) of Cote d'Ivoire in 2012 to that in 2013?
Your answer should be very brief. 0.97. What is the ratio of the Rating (1=low 6=high) in Guinea-Bissau in 2012 to that in 2013?
Your answer should be very brief. 1.04. What is the difference between the highest and the second highest Rating (1=low 6=high) in Latin America(all income levels)?
Offer a terse response. 0.02. What is the difference between the highest and the second highest Rating (1=low 6=high) in Afghanistan?
Ensure brevity in your answer.  0. What is the difference between the highest and the second highest Rating (1=low 6=high) in Cote d'Ivoire?
Give a very brief answer. 0.1. What is the difference between the highest and the lowest Rating (1=low 6=high) in Latin America(all income levels)?
Ensure brevity in your answer.  0.08. What is the difference between the highest and the lowest Rating (1=low 6=high) in Cote d'Ivoire?
Offer a very short reply. 0.6. What is the difference between the highest and the lowest Rating (1=low 6=high) of Guinea-Bissau?
Your response must be concise. 0.3. 